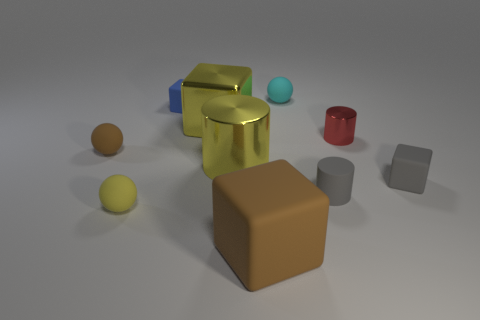Subtract all cubes. How many objects are left? 6 Add 2 small red shiny cubes. How many small red shiny cubes exist? 2 Subtract 1 cyan balls. How many objects are left? 9 Subtract all blue rubber blocks. Subtract all large matte blocks. How many objects are left? 8 Add 3 tiny rubber balls. How many tiny rubber balls are left? 6 